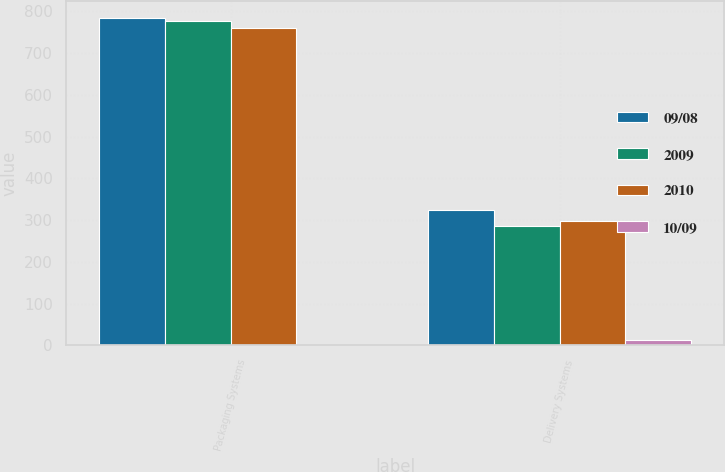Convert chart to OTSL. <chart><loc_0><loc_0><loc_500><loc_500><stacked_bar_chart><ecel><fcel>Packaging Systems<fcel>Delivery Systems<nl><fcel>09/08<fcel>785<fcel>324.1<nl><fcel>2009<fcel>776<fcel>285<nl><fcel>2010<fcel>760.4<fcel>297.9<nl><fcel>10/09<fcel>1.2<fcel>13.7<nl></chart> 